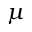Convert formula to latex. <formula><loc_0><loc_0><loc_500><loc_500>\mu</formula> 